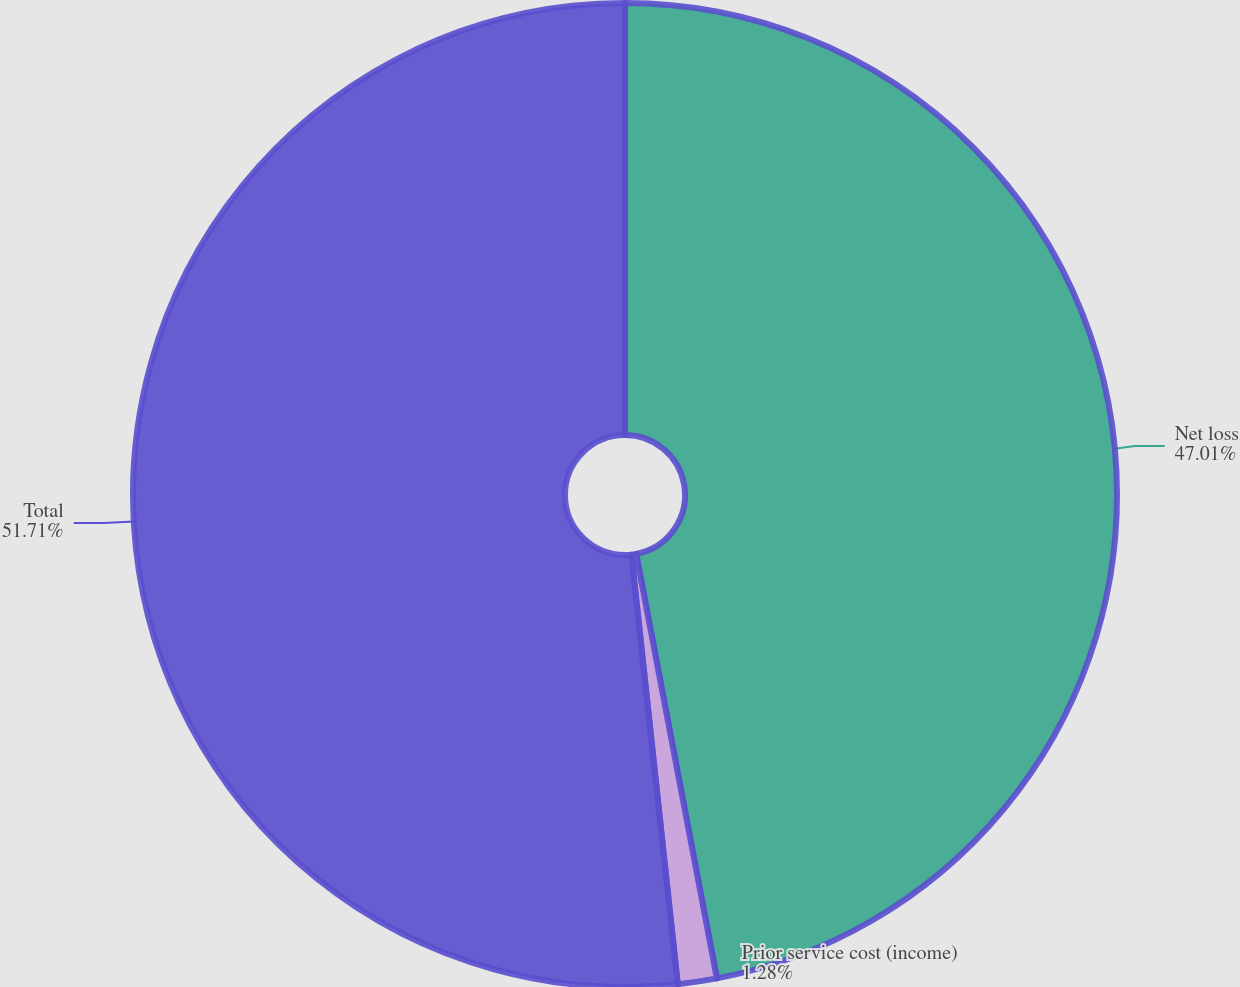Convert chart. <chart><loc_0><loc_0><loc_500><loc_500><pie_chart><fcel>Net loss<fcel>Prior service cost (income)<fcel>Total<nl><fcel>47.01%<fcel>1.28%<fcel>51.71%<nl></chart> 